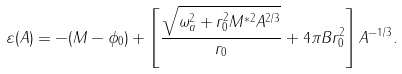<formula> <loc_0><loc_0><loc_500><loc_500>\varepsilon ( A ) = - ( M - \phi _ { 0 } ) + \left [ \frac { \sqrt { \omega _ { a } ^ { 2 } + r _ { 0 } ^ { 2 } M ^ { \ast 2 } A ^ { 2 / 3 } } } { r _ { 0 } } + 4 \pi B r _ { 0 } ^ { 2 } \right ] A ^ { - 1 / 3 } .</formula> 